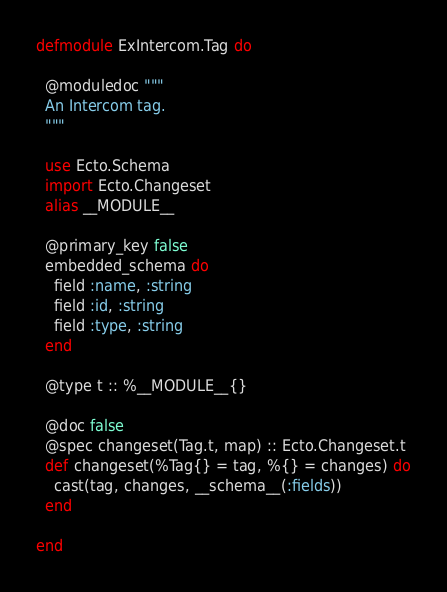<code> <loc_0><loc_0><loc_500><loc_500><_Elixir_>defmodule ExIntercom.Tag do

  @moduledoc """
  An Intercom tag.
  """

  use Ecto.Schema
  import Ecto.Changeset
  alias __MODULE__

  @primary_key false
  embedded_schema do
    field :name, :string
    field :id, :string
    field :type, :string
  end

  @type t :: %__MODULE__{}

  @doc false
  @spec changeset(Tag.t, map) :: Ecto.Changeset.t
  def changeset(%Tag{} = tag, %{} = changes) do
    cast(tag, changes, __schema__(:fields))
  end

end
</code> 